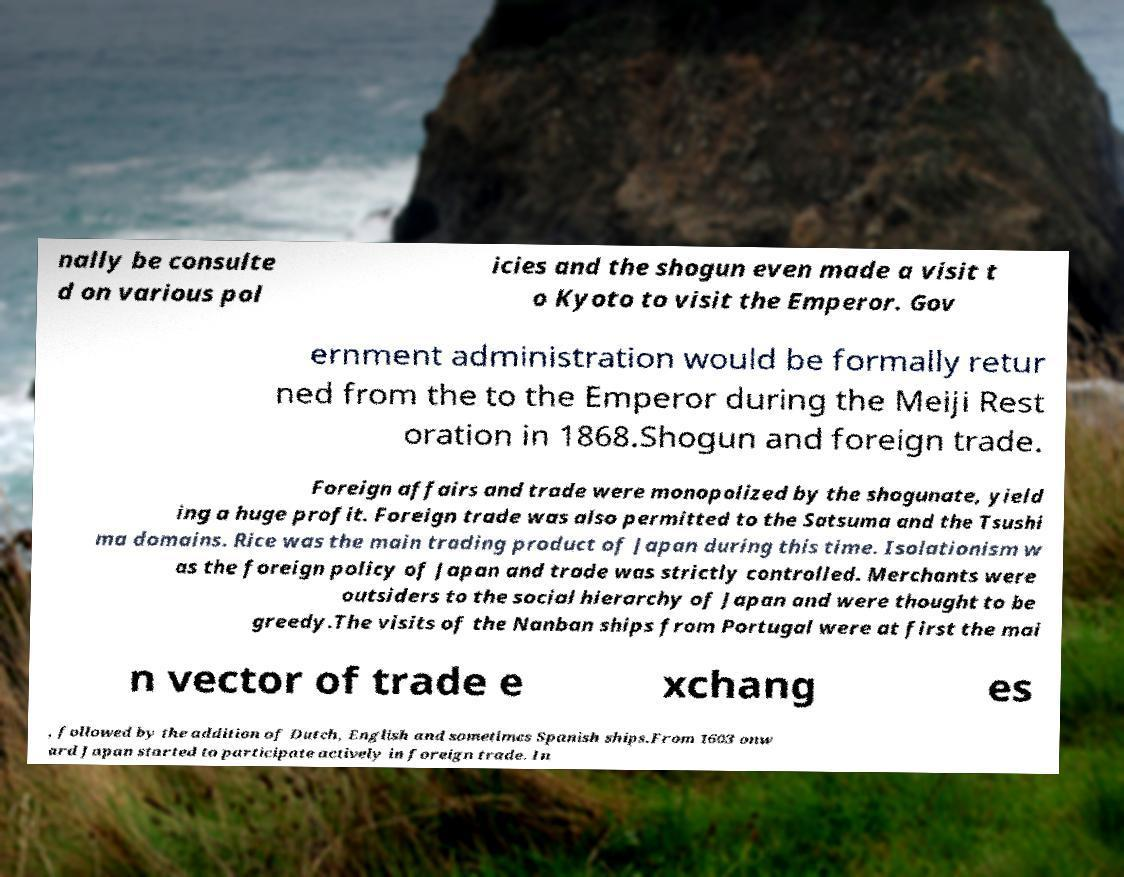Please identify and transcribe the text found in this image. nally be consulte d on various pol icies and the shogun even made a visit t o Kyoto to visit the Emperor. Gov ernment administration would be formally retur ned from the to the Emperor during the Meiji Rest oration in 1868.Shogun and foreign trade. Foreign affairs and trade were monopolized by the shogunate, yield ing a huge profit. Foreign trade was also permitted to the Satsuma and the Tsushi ma domains. Rice was the main trading product of Japan during this time. Isolationism w as the foreign policy of Japan and trade was strictly controlled. Merchants were outsiders to the social hierarchy of Japan and were thought to be greedy.The visits of the Nanban ships from Portugal were at first the mai n vector of trade e xchang es , followed by the addition of Dutch, English and sometimes Spanish ships.From 1603 onw ard Japan started to participate actively in foreign trade. In 